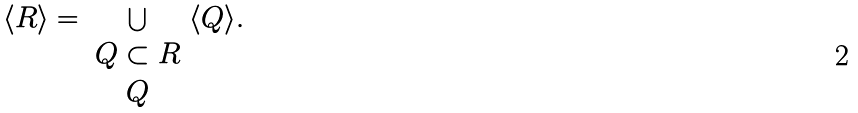<formula> <loc_0><loc_0><loc_500><loc_500>\langle R \rangle = \bigcup _ { \begin{array} { c } Q \subset R \\ Q \end{array} } \langle Q \rangle .</formula> 